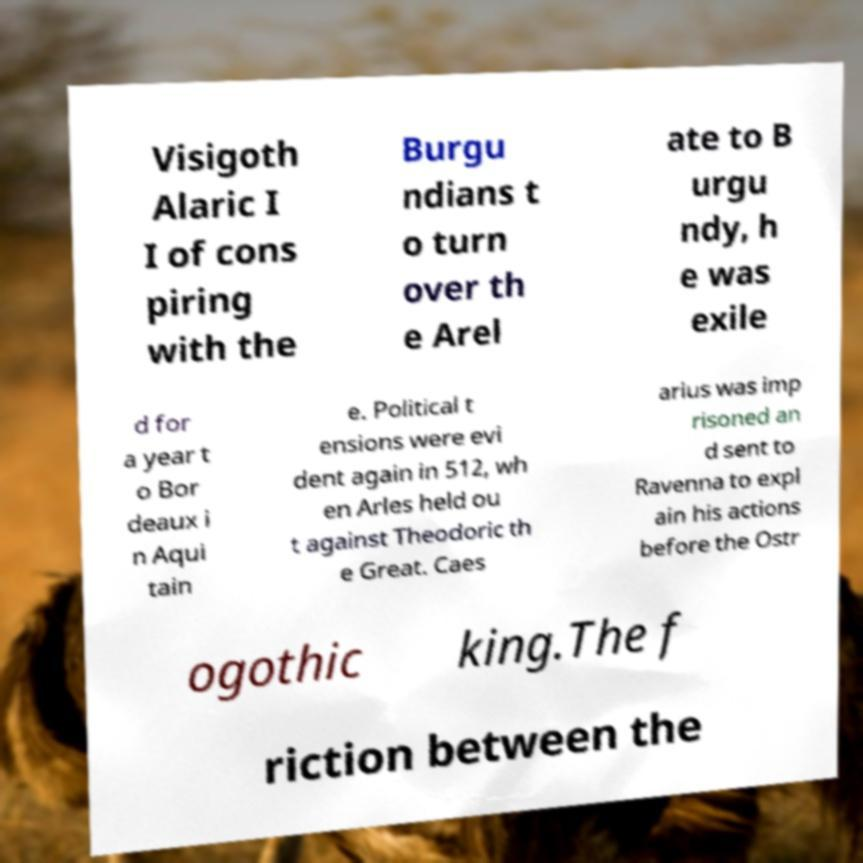Please identify and transcribe the text found in this image. Visigoth Alaric I I of cons piring with the Burgu ndians t o turn over th e Arel ate to B urgu ndy, h e was exile d for a year t o Bor deaux i n Aqui tain e. Political t ensions were evi dent again in 512, wh en Arles held ou t against Theodoric th e Great. Caes arius was imp risoned an d sent to Ravenna to expl ain his actions before the Ostr ogothic king.The f riction between the 